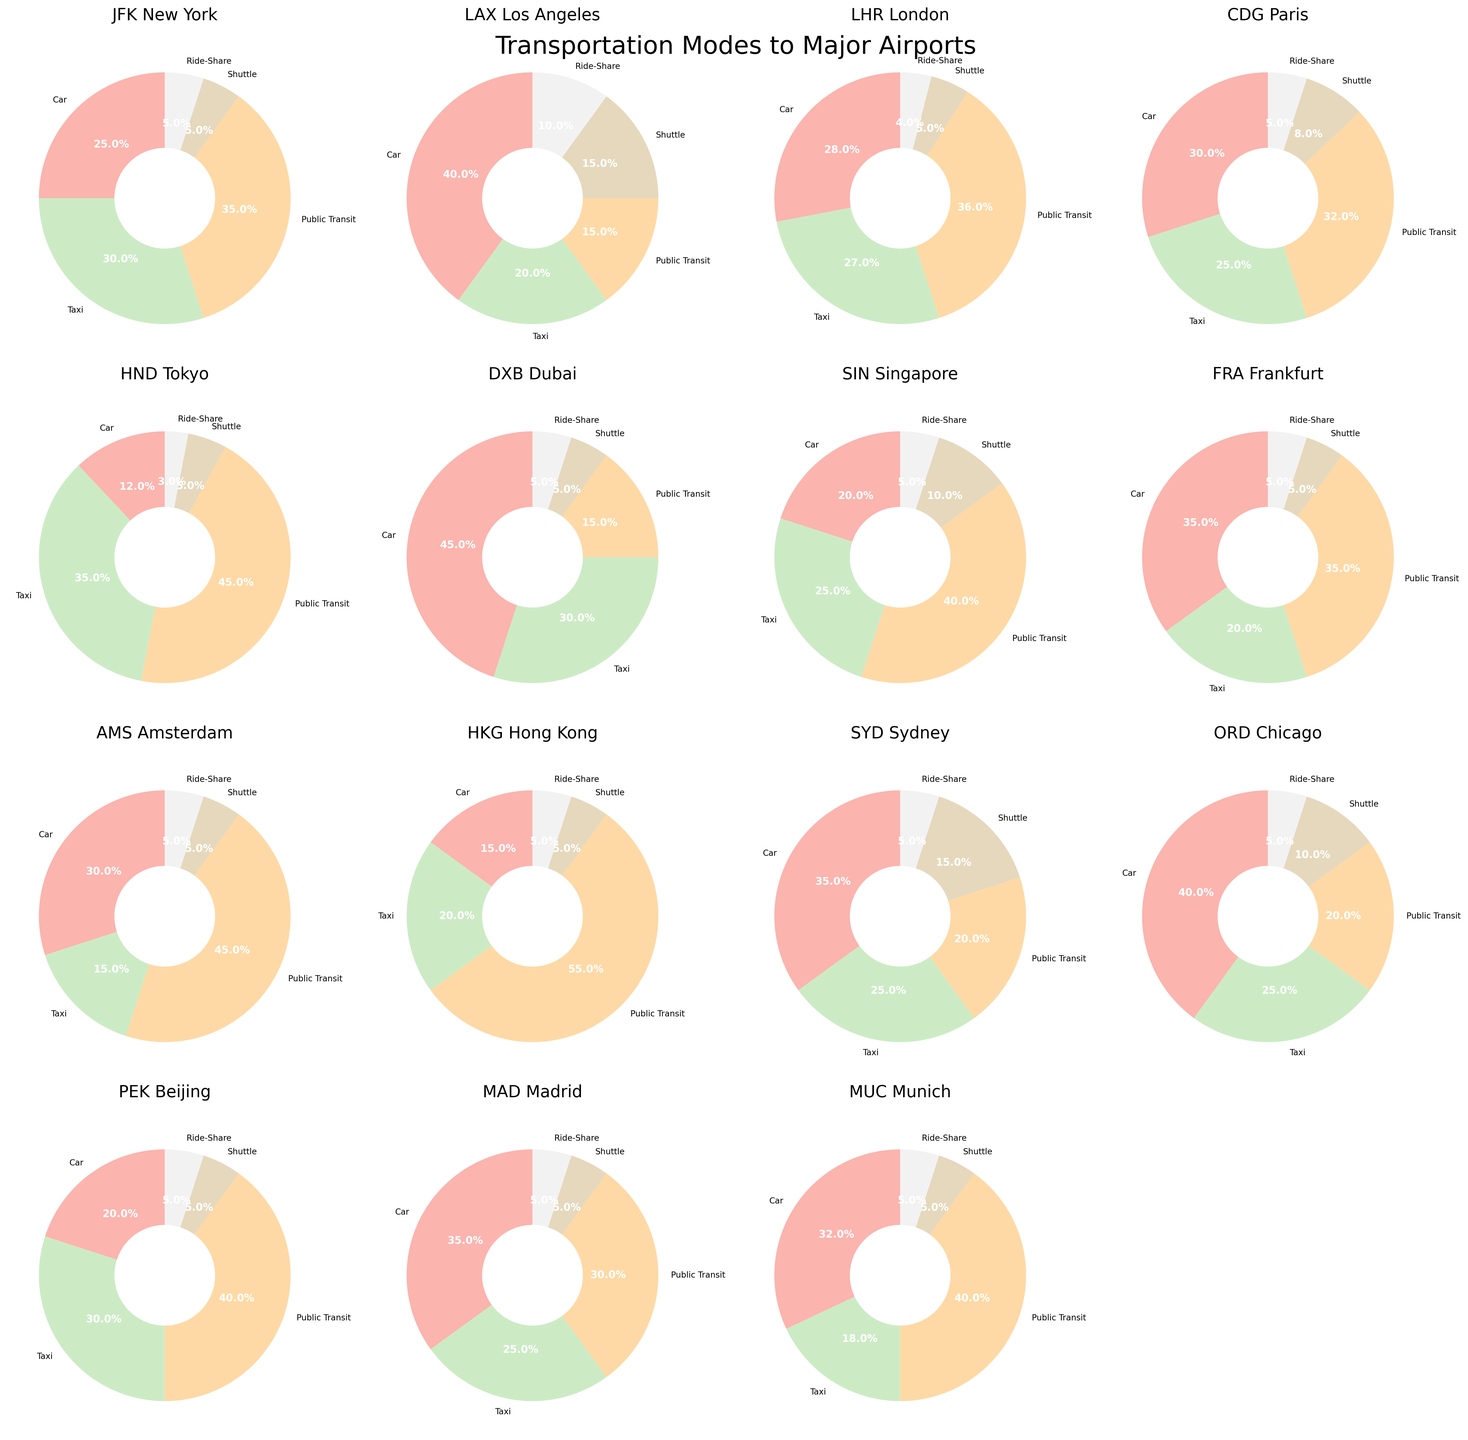Which airport has the highest percentage of passengers using Public Transit? First, identify the pie chart segments representing Public Transit for each airport. Then, determine which airport shows the largest percentage.
Answer: HKG Hong Kong Which airports have an equal percentage of passengers using Shuttle services? Check the pie chart segments representing Shuttle services for all airports. Identify the airports where the percentage for Shuttle is the same.
Answer: JFK New York, LHR London, HND Tokyo, DXB Dubai, AMS Amsterdam, PEK Beijing, MAD Madrid, MUC Munich (all have 5%) Which form of transportation is most popular for reaching LAX Los Angeles? Refer to the LAX Los Angeles pie chart and look for the transportation mode with the largest percentage.
Answer: Car Among JFK New York, LHR London, and CDG Paris, which airport has the lowest percentage of passengers using Ride-Share? Compare the Ride-Share segments of the pie charts for JFK New York, LHR London, and CDG Paris.
Answer: LHR London What is the sum of the percentages of passengers using Car and Taxi for ORD Chicago? Add the Car and Taxi segments in the ORD Chicago pie chart. Car is 40% and Taxi is 25%, so 40 + 25 = 65
Answer: 65% Compare the percentage of passengers using Public Transit between SIN Singapore and AMS Amsterdam. Which has a higher percentage and by how much? Identify the Public Transit segments in the SIN Singapore and AMS Amsterdam pie charts. SIN Singapore has 40% and AMS Amsterdam has 45%. The difference is 45 - 40 = 5
Answer: AMS Amsterdam, 5% Which airport has the most balanced distribution across all transportation modes? Look at all pie charts and assess which one has the segments closest in size, representing a balanced distribution.
Answer: SIN Singapore For HND Tokyo, what is the combined percentage of passengers using Car and Ride-Share? Add the Car and Ride-Share segments in the HND Tokyo pie chart. Car is 12% and Ride-Share is 3%, so 12 + 3 = 15
Answer: 15% Which mode of transportation is least used overall (summed across all airports)? Sum the percentages of each transportation mode across all airports and find the lowest total. Shuttle appears to be the least common.
Answer: Shuttle How many airports have more than 30% of passengers using Public Transit? Count the number of airports where the Public Transit segment is greater than 30%. This includes JFK New York, LHR London, HND Tokyo, SIN Singapore, AMS Amsterdam, HKG Hong Kong, PEK Beijing, and MUC Munich.
Answer: 8 